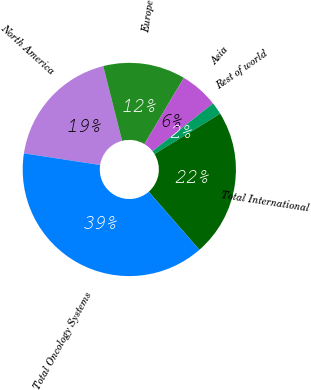Convert chart. <chart><loc_0><loc_0><loc_500><loc_500><pie_chart><fcel>North America<fcel>Europe<fcel>Asia<fcel>Rest of world<fcel>Total International<fcel>Total Oncology Systems<nl><fcel>18.65%<fcel>12.48%<fcel>5.82%<fcel>1.88%<fcel>22.34%<fcel>38.83%<nl></chart> 